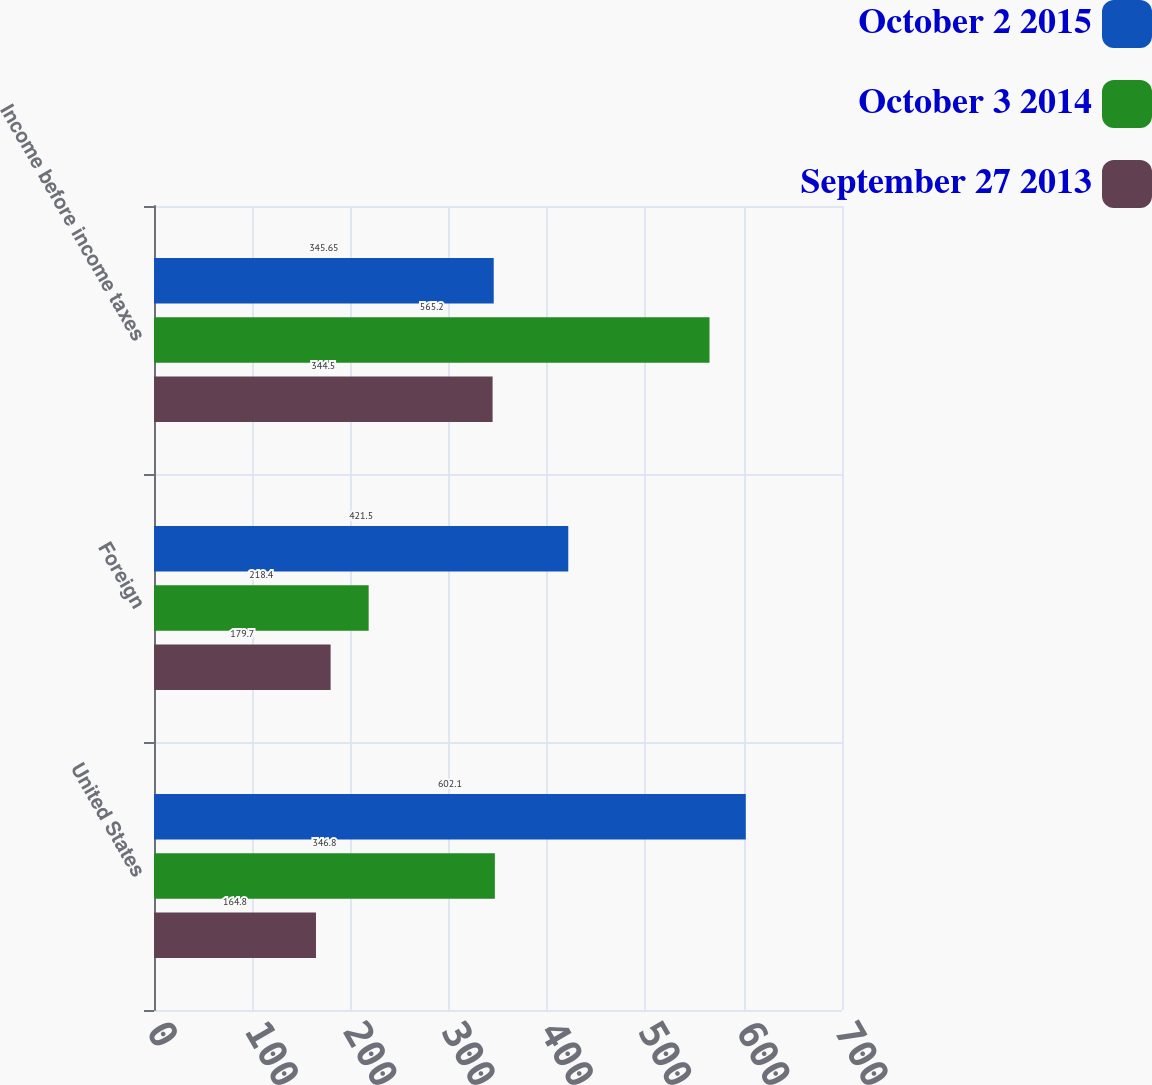Convert chart. <chart><loc_0><loc_0><loc_500><loc_500><stacked_bar_chart><ecel><fcel>United States<fcel>Foreign<fcel>Income before income taxes<nl><fcel>October 2 2015<fcel>602.1<fcel>421.5<fcel>345.65<nl><fcel>October 3 2014<fcel>346.8<fcel>218.4<fcel>565.2<nl><fcel>September 27 2013<fcel>164.8<fcel>179.7<fcel>344.5<nl></chart> 